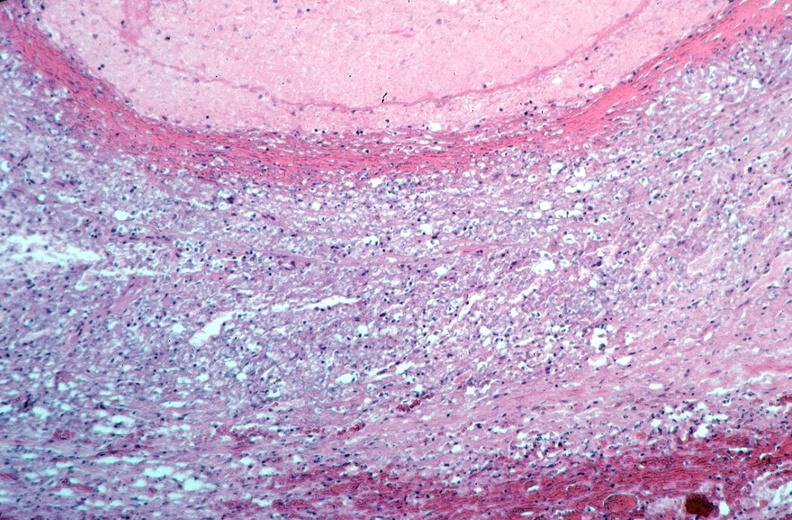what is present?
Answer the question using a single word or phrase. Cardiovascular 